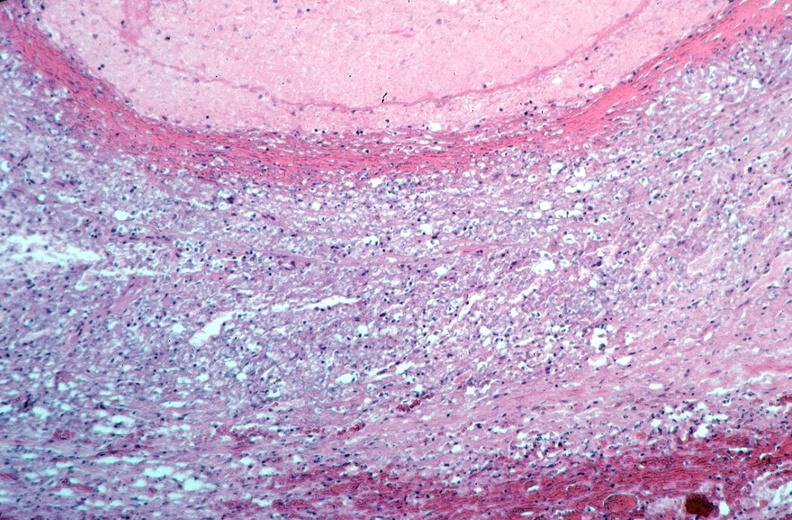what is present?
Answer the question using a single word or phrase. Cardiovascular 